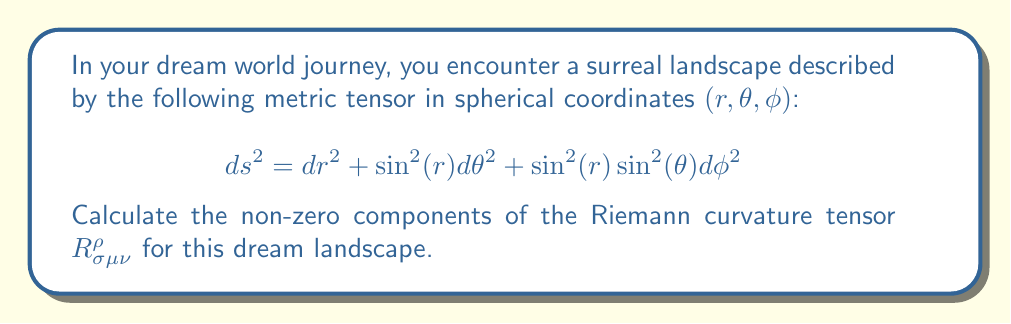Show me your answer to this math problem. To calculate the Riemann curvature tensor, we'll follow these steps:

1) First, we need to identify the metric components:
   $g_{rr} = 1$, $g_{\theta\theta} = \sin^2(r)$, $g_{\phi\phi} = \sin^2(r)\sin^2(\theta)$

2) Calculate the Christoffel symbols using:
   $$\Gamma^{\lambda}_{\mu\nu} = \frac{1}{2}g^{\lambda\sigma}(\partial_\mu g_{\nu\sigma} + \partial_\nu g_{\mu\sigma} - \partial_\sigma g_{\mu\nu})$$

   Non-zero Christoffel symbols are:
   $\Gamma^r_{\theta\theta} = -\sin(r)\cos(r)$
   $\Gamma^r_{\phi\phi} = -\sin(r)\cos(r)\sin^2(\theta)$
   $\Gamma^\theta_{r\theta} = \Gamma^\theta_{\theta r} = \cot(r)$
   $\Gamma^\theta_{\phi\phi} = -\sin(\theta)\cos(\theta)$
   $\Gamma^\phi_{r\phi} = \Gamma^\phi_{\phi r} = \cot(r)$
   $\Gamma^\phi_{\theta\phi} = \Gamma^\phi_{\phi\theta} = \cot(\theta)$

3) Use the Riemann tensor formula:
   $$R^{\rho}_{\sigma\mu\nu} = \partial_\mu\Gamma^{\rho}_{\nu\sigma} - \partial_\nu\Gamma^{\rho}_{\mu\sigma} + \Gamma^{\rho}_{\mu\lambda}\Gamma^{\lambda}_{\nu\sigma} - \Gamma^{\rho}_{\nu\lambda}\Gamma^{\lambda}_{\mu\sigma}$$

4) Calculate the non-zero components:
   $R^r_{\theta r \theta} = \sin^2(r)$
   $R^r_{\phi r \phi} = \sin^2(r)\sin^2(\theta)$
   $R^\theta_{\phi \theta \phi} = \sin^2(r)\sin^2(\theta)$
   
   Other components can be derived from these using the symmetries of the Riemann tensor.

5) The remaining non-zero components are:
   $R^r_{\theta \theta r} = -R^r_{\theta r \theta}$
   $R^r_{\phi \phi r} = -R^r_{\phi r \phi}$
   $R^\theta_{\phi \phi \theta} = -R^\theta_{\phi \theta \phi}$
   $R^\phi_{r \phi r} = -\sin^2(r)\sin^2(\theta)$
   $R^\phi_{\theta \phi \theta} = -\sin^2(r)\sin^2(\theta)$
Answer: $R^r_{\theta r \theta} = \sin^2(r)$, $R^r_{\phi r \phi} = \sin^2(r)\sin^2(\theta)$, $R^\theta_{\phi \theta \phi} = \sin^2(r)\sin^2(\theta)$, and their symmetries. 